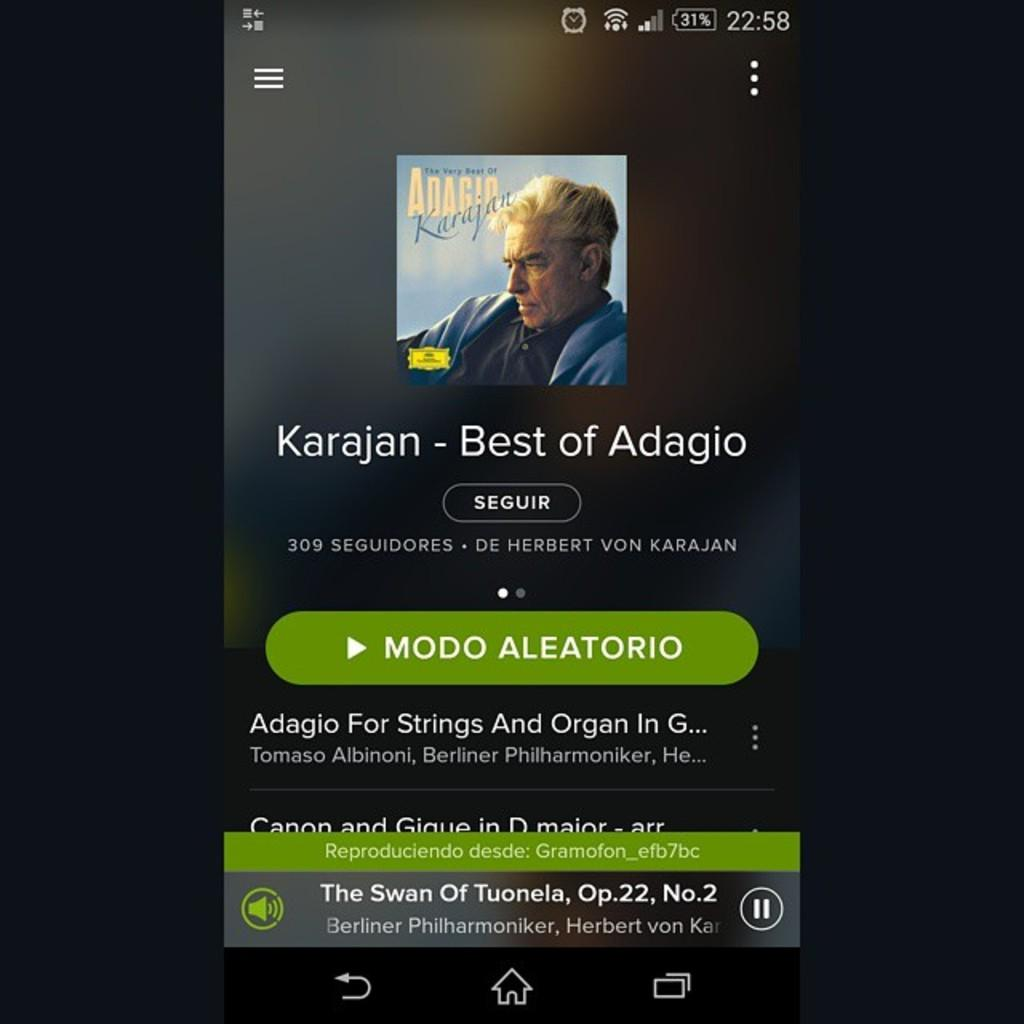<image>
Give a short and clear explanation of the subsequent image. A poster advertising the Best of Adagio by Karajan 